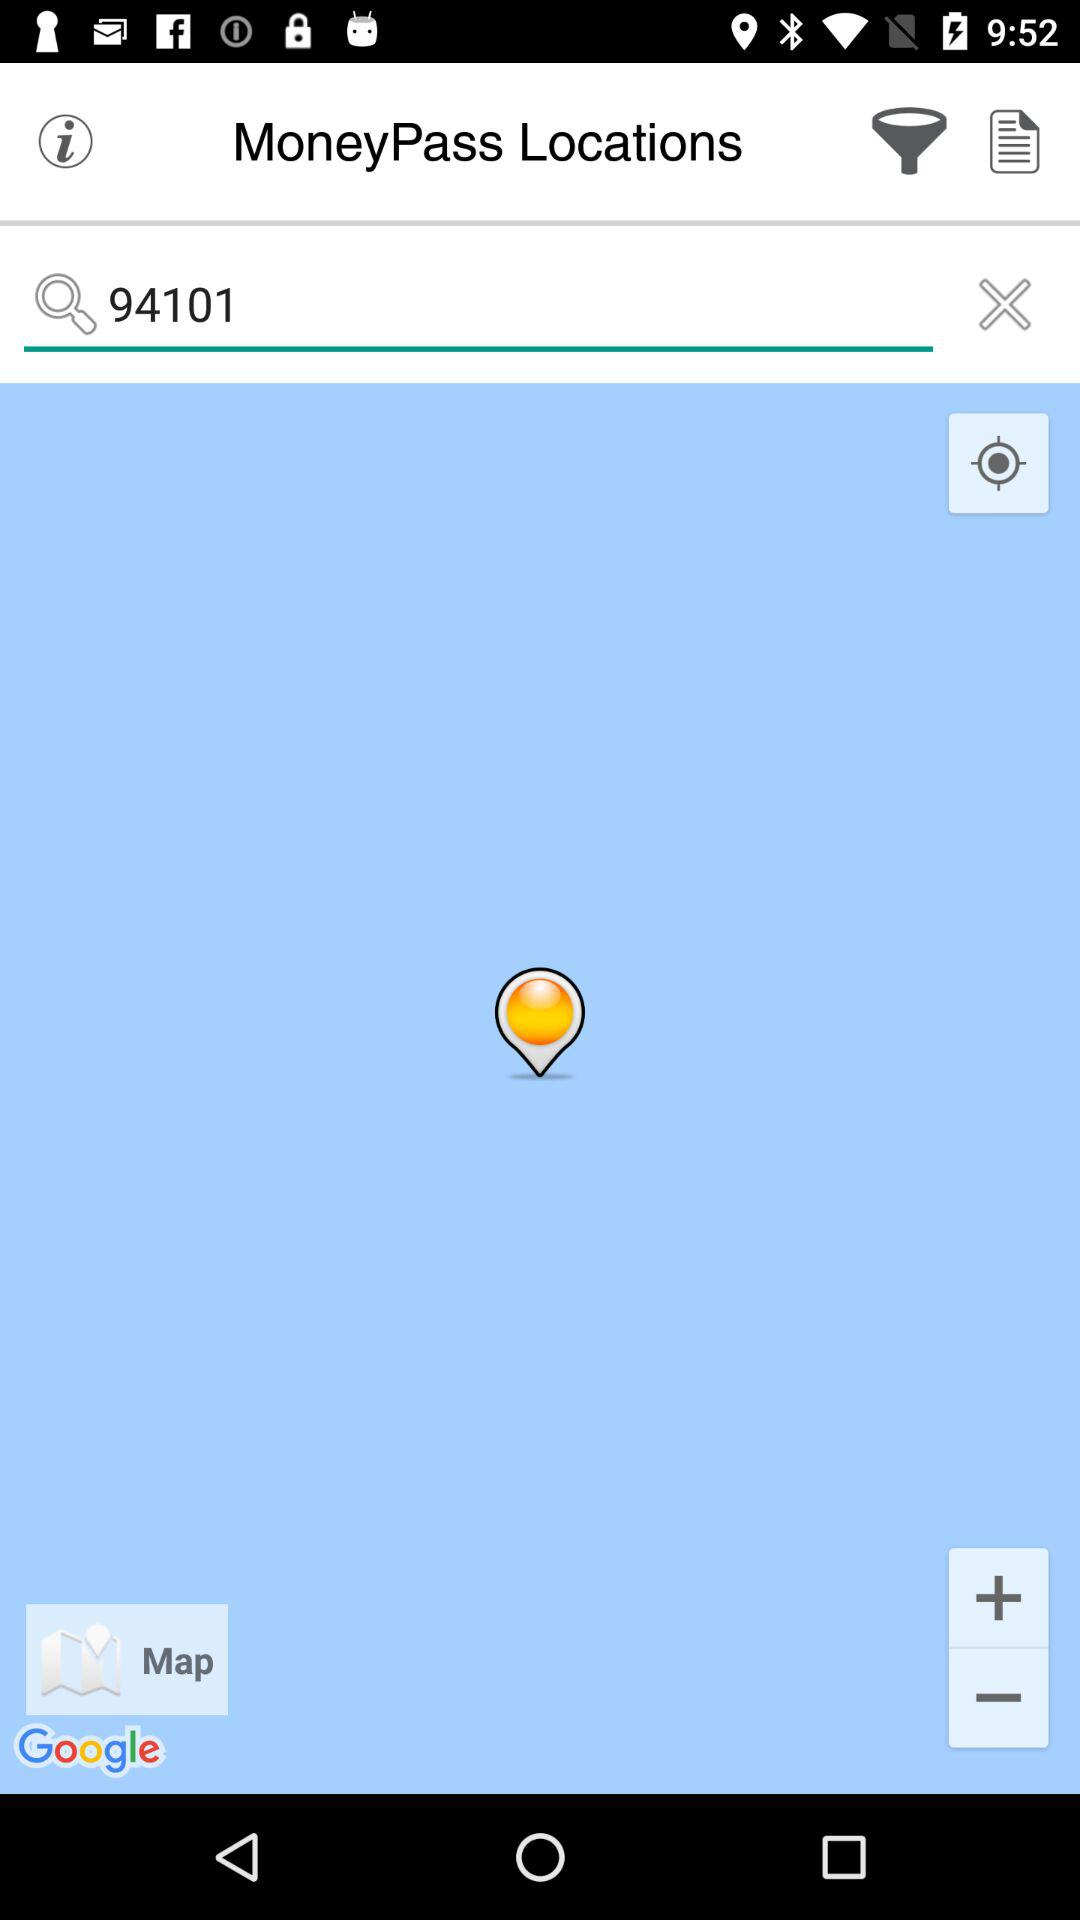What is the app name? The app names are "MoneyPass" and "MoneyPass ATM Locator". 